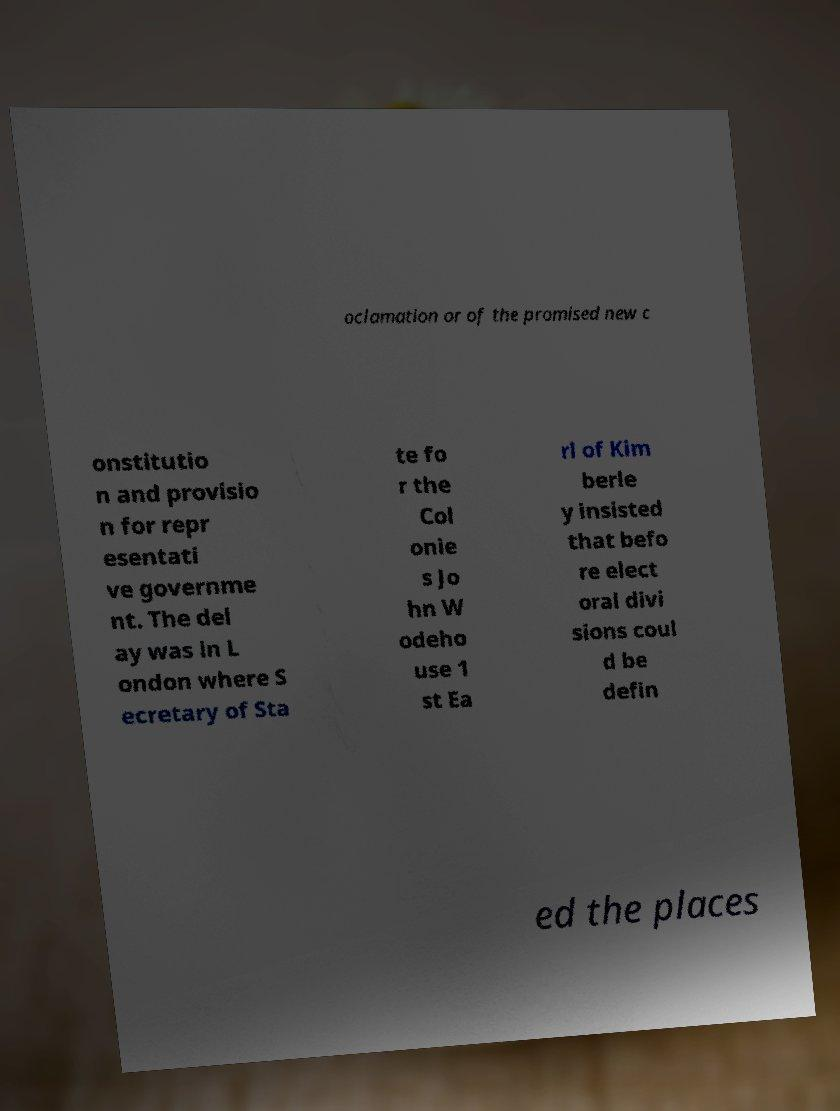There's text embedded in this image that I need extracted. Can you transcribe it verbatim? oclamation or of the promised new c onstitutio n and provisio n for repr esentati ve governme nt. The del ay was in L ondon where S ecretary of Sta te fo r the Col onie s Jo hn W odeho use 1 st Ea rl of Kim berle y insisted that befo re elect oral divi sions coul d be defin ed the places 